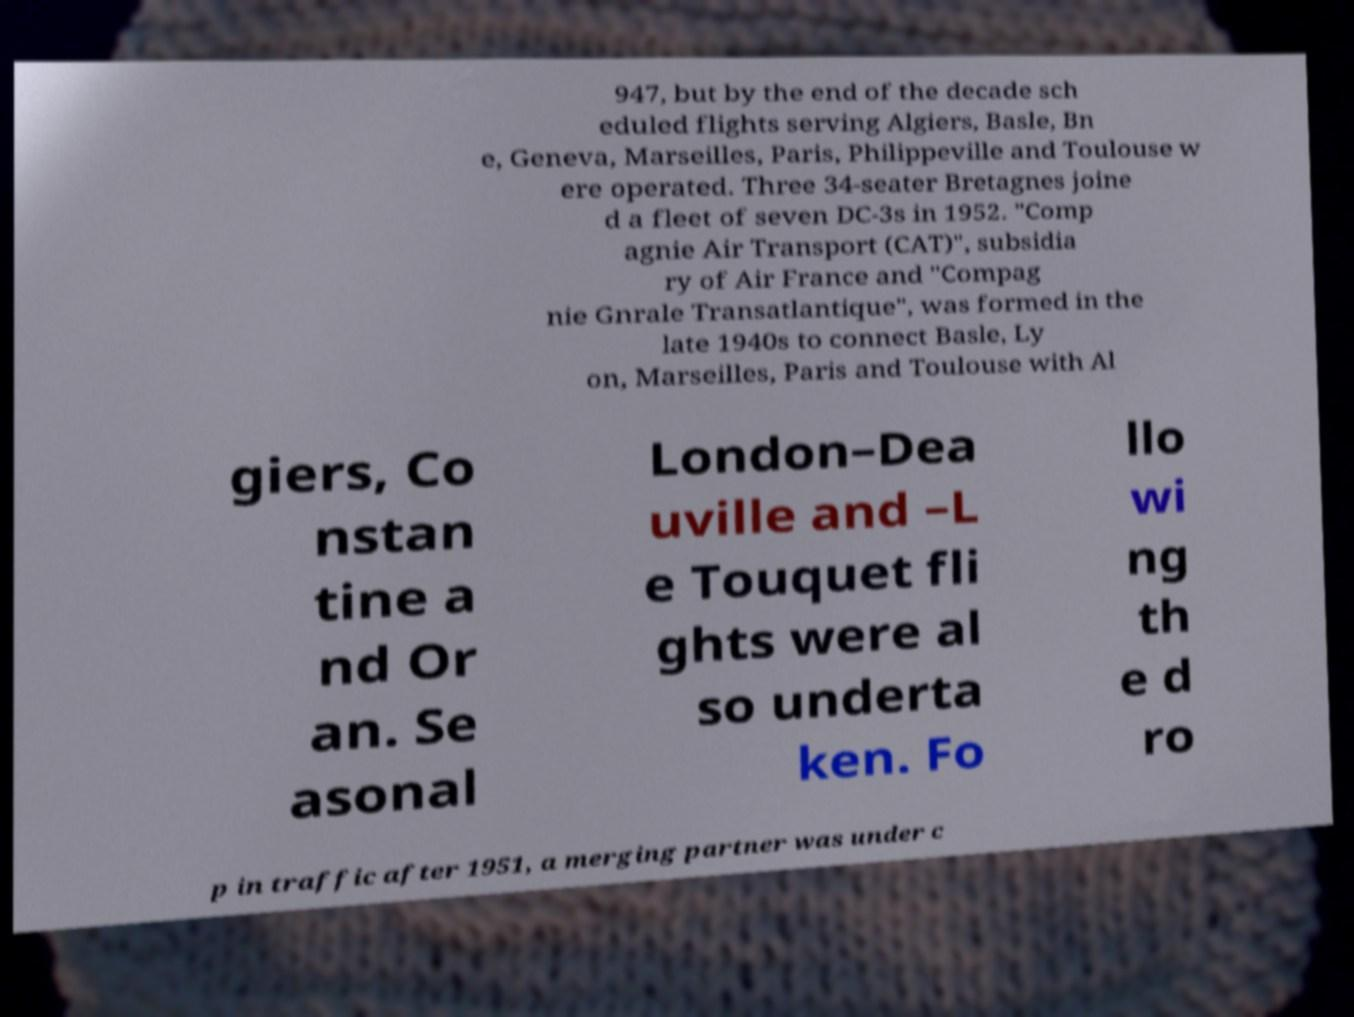Could you extract and type out the text from this image? 947, but by the end of the decade sch eduled flights serving Algiers, Basle, Bn e, Geneva, Marseilles, Paris, Philippeville and Toulouse w ere operated. Three 34-seater Bretagnes joine d a fleet of seven DC-3s in 1952. "Comp agnie Air Transport (CAT)", subsidia ry of Air France and "Compag nie Gnrale Transatlantique", was formed in the late 1940s to connect Basle, Ly on, Marseilles, Paris and Toulouse with Al giers, Co nstan tine a nd Or an. Se asonal London–Dea uville and –L e Touquet fli ghts were al so underta ken. Fo llo wi ng th e d ro p in traffic after 1951, a merging partner was under c 